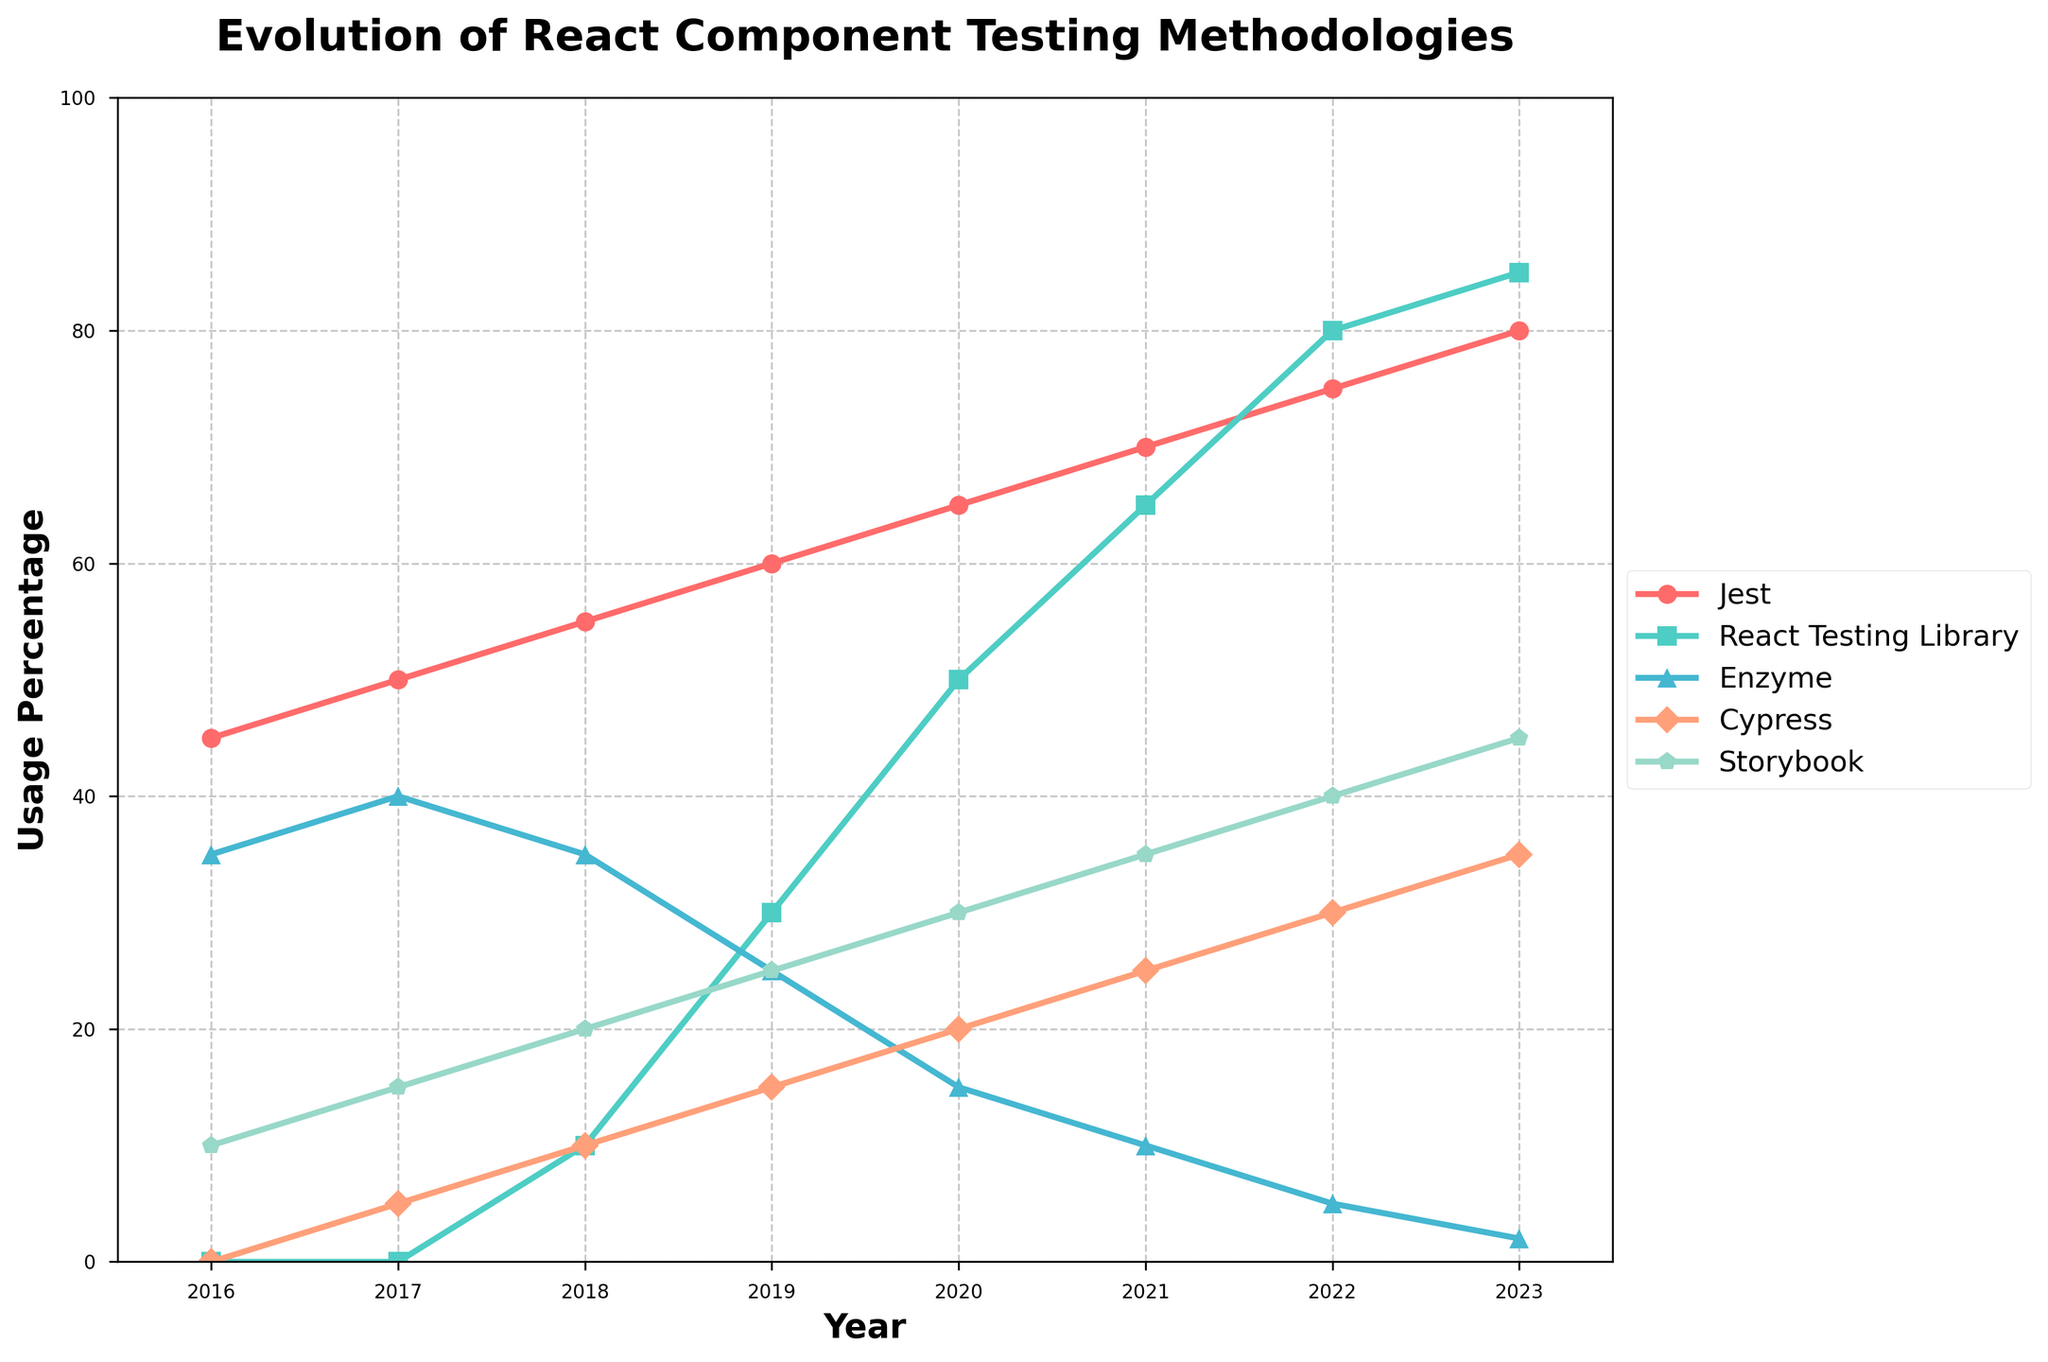What is the title of the chart? The title of the chart is located at the top and reads "Evolution of React Component Testing Methodologies." This provides an overview of the graph's focus on how different testing methodologies have changed over time.
Answer: Evolution of React Component Testing Methodologies How many testing methodologies are plotted in the figure? There are five different lines in the chart representing five testing methodologies: Jest, React Testing Library, Enzyme, Cypress, and Storybook. We can identify them by counting the distinct lines or checking the legend.
Answer: 5 Which methodology had the highest usage percentage in 2023? We can look at the end of each line (the data point corresponding to the year 2023) and identify which one is the highest. React Testing Library ends at the highest point.
Answer: React Testing Library How much did Jest's usage percentage increase between 2016 and 2023? Jest's usage percentage in 2016 is 45, and in 2023 it is 80. The increase can be calculated by subtracting 45 from 80.
Answer: 35 In which year did Cypress first appear in the chart? We need to trace the line representing Cypress to its first non-zero data point, which is in 2017.
Answer: 2017 What is the difference in usage percentage between React Testing Library and Enzyme in 2020? For 2020, React Testing Library has 50% and Enzyme has 15%. The difference is 50 - 15.
Answer: 35 Which methodology had the steepest rise in the first three years of its appearance? We should examine the slopes of the lines within the first three data points for each methodology. React Testing Library increased from 0 in 2017 to 30 in 2019, a steep rise of 30 points in three years.
Answer: React Testing Library How did the usage of Storybook change between 2019 and 2023? Storybook's usage percentage in 2019 is 25, and in 2023 it is 45. The change is calculated by subtracting 25 from 45.
Answer: Increased by 20 In 2018, which testing methodology was in second place in terms of usage percentage? For 2018, we need to look at all the values and identify the second highest. Jest is the highest at 55, and Enzyme is second at 35.
Answer: Enzyme Between 2016 and 2023, which methodology showed the most decline? Enzyme has a decline from 35 in 2016 to 2 in 2023, a decline of 33.
Answer: Enzyme 